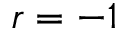Convert formula to latex. <formula><loc_0><loc_0><loc_500><loc_500>r = - 1</formula> 